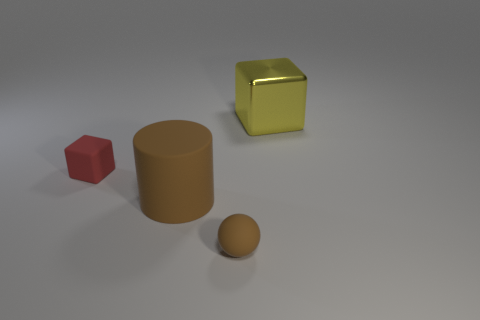There is a red thing that is made of the same material as the sphere; what shape is it?
Your response must be concise. Cube. Is the size of the brown object in front of the brown cylinder the same as the cube that is behind the tiny matte block?
Ensure brevity in your answer.  No. Is the number of shiny things in front of the metallic thing greater than the number of big brown things that are in front of the small ball?
Provide a short and direct response. No. What number of other things are the same color as the cylinder?
Keep it short and to the point. 1. There is a big cube; does it have the same color as the block that is to the left of the metallic thing?
Give a very brief answer. No. There is a large object in front of the yellow thing; what number of big objects are behind it?
Your answer should be compact. 1. Are there any other things that have the same material as the small brown object?
Make the answer very short. Yes. There is a big thing to the left of the cube that is on the right side of the cube to the left of the ball; what is it made of?
Ensure brevity in your answer.  Rubber. The thing that is behind the brown matte ball and right of the large brown cylinder is made of what material?
Your answer should be very brief. Metal. What number of other things are the same shape as the red rubber object?
Ensure brevity in your answer.  1. 